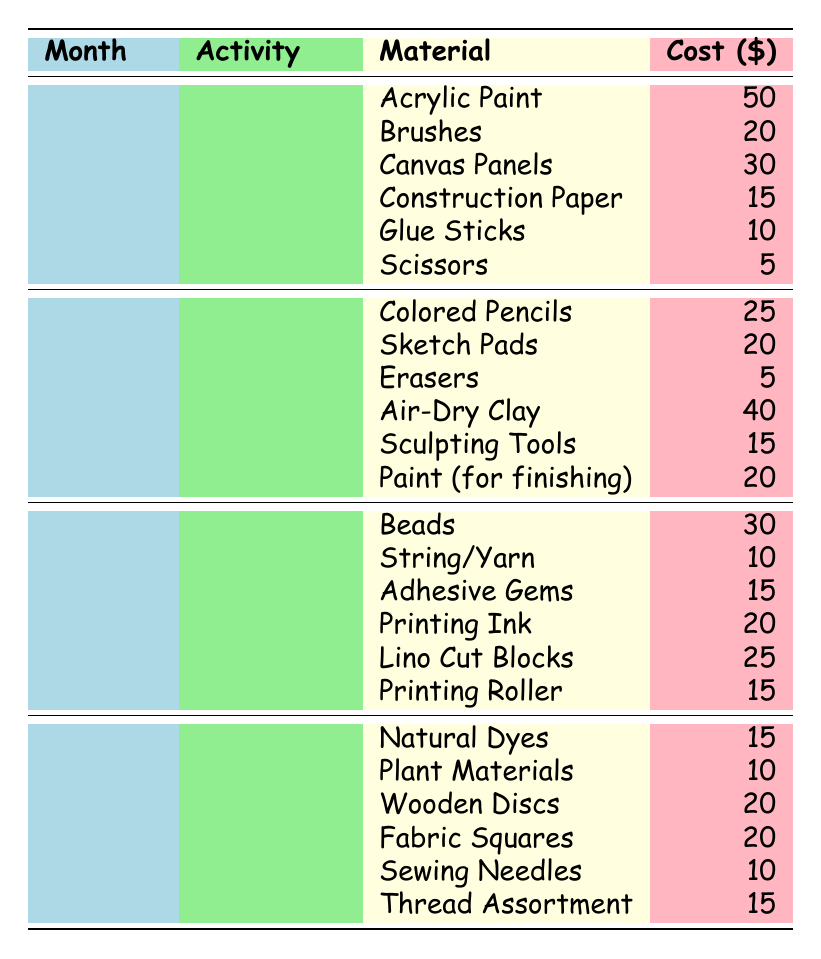What was the total cost of materials for Painting in January? The Painting activity in January has three materials: Acrylic Paint costing 50, Brushes costing 20, and Canvas Panels costing 30. To find the total cost, we add these values: 50 + 20 + 30 = 100.
Answer: 100 Which month had the highest total cost for Sculpture materials? In February, the Sculpture materials total is calculated as follows: Air-Dry Clay (40) + Sculpting Tools (15) + Paint (for finishing) (20) = 75. It is the only month that features Sculpture, so February is also the month with the highest cost for Sculpture materials.
Answer: February Is the cost of Colored Pencils greater than the cost of Thread Assortment? The cost for Colored Pencils is 25 and the cost for Thread Assortment is 15. Since 25 is greater than 15, the statement is true.
Answer: Yes What was the average cost of materials for Crafting in March? There are three materials for Crafting in March: Beads (30), String/Yarn (10), and Adhesive Gems (15). To find the average, we first calculate the total: 30 + 10 + 15 = 55. Then, we divide by the number of materials (3): 55/3 = approximately 18.33.
Answer: 18.33 What is the total cost of all the materials for Nature Art in April? For the Nature Art activity in April, there are three materials: Natural Dyes (15), Plant Materials (10), and Wooden Discs (20). Adding these costs together gives us 15 + 10 + 20 = 45.
Answer: 45 In which month is the total cost for Collage materials less than 50? The total for Collage materials in January is calculated as follows: Construction Paper (15) + Glue Sticks (10) + Scissors (5) = 30, which is less than 50. Therefore, January is the month where Collage materials cost less than 50.
Answer: January What was the sum of costs for all the materials in February? In February, we have two activities: Drawing and Sculpture. The costs for Drawing are: Colored Pencils (25) + Sketch Pads (20) + Erasers (5) = 50. For Sculpture, we calculate: Air-Dry Clay (40) + Sculpting Tools (15) + Paint (20) = 75. Now, we find the sum of both totals: 50 + 75 = 125.
Answer: 125 Are the total costs for activities in April greater than the total in January? In April, the total costs are for Nature Art (15 + 10 + 20 = 45) and Textiles (20 + 10 + 15 = 45), giving a total of 45 + 45 = 90. In January, the total costs are for Painting (50 + 20 + 30 = 100) and Collage (15 + 10 + 5 = 30), giving a total of 100 + 30 = 130. Since 90 is less than 130, the statement is false.
Answer: No 